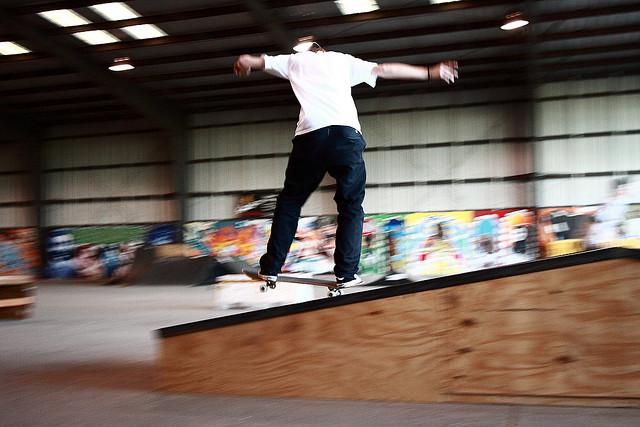Is the picture clear?
Give a very brief answer. No. Is he wearing a watch?
Be succinct. Yes. Is the person moving?
Quick response, please. Yes. 